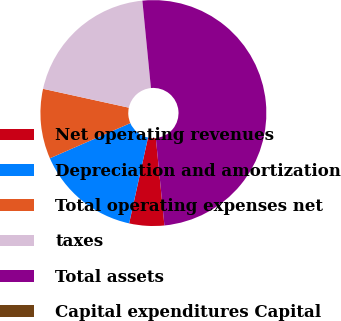<chart> <loc_0><loc_0><loc_500><loc_500><pie_chart><fcel>Net operating revenues<fcel>Depreciation and amortization<fcel>Total operating expenses net<fcel>taxes<fcel>Total assets<fcel>Capital expenditures Capital<nl><fcel>5.0%<fcel>15.0%<fcel>10.0%<fcel>20.0%<fcel>50.0%<fcel>0.0%<nl></chart> 